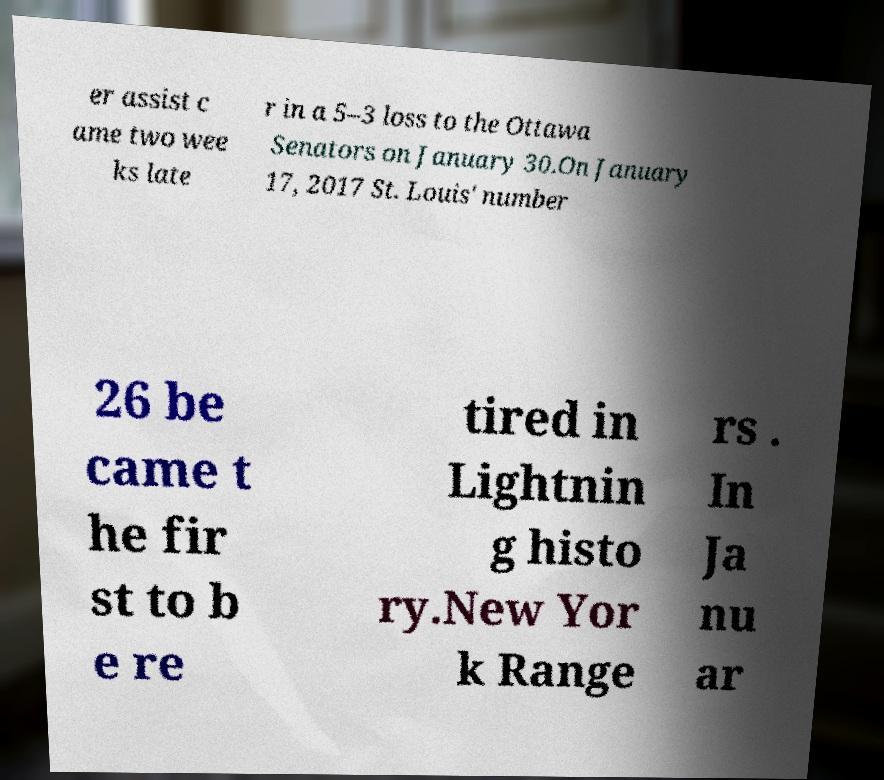I need the written content from this picture converted into text. Can you do that? er assist c ame two wee ks late r in a 5–3 loss to the Ottawa Senators on January 30.On January 17, 2017 St. Louis' number 26 be came t he fir st to b e re tired in Lightnin g histo ry.New Yor k Range rs . In Ja nu ar 